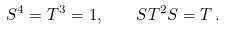Convert formula to latex. <formula><loc_0><loc_0><loc_500><loc_500>S ^ { 4 } = T ^ { 3 } = 1 , \quad S T ^ { 2 } S = T \, .</formula> 